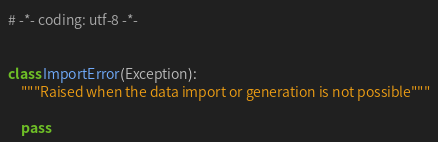<code> <loc_0><loc_0><loc_500><loc_500><_Python_># -*- coding: utf-8 -*-


class ImportError(Exception):
    """Raised when the data import or generation is not possible"""

    pass
</code> 